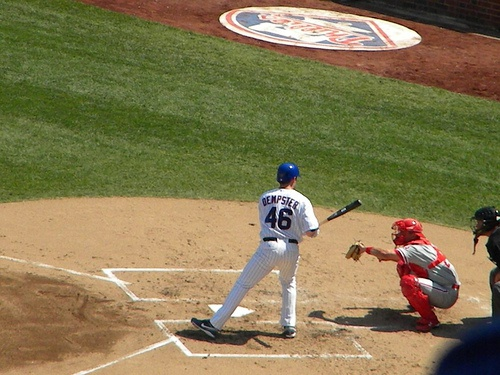Describe the objects in this image and their specific colors. I can see people in olive, gray, white, and black tones, people in olive, maroon, gray, brown, and black tones, people in olive, black, gray, maroon, and darkgreen tones, baseball bat in olive, black, tan, and gray tones, and baseball glove in olive, maroon, brown, and black tones in this image. 